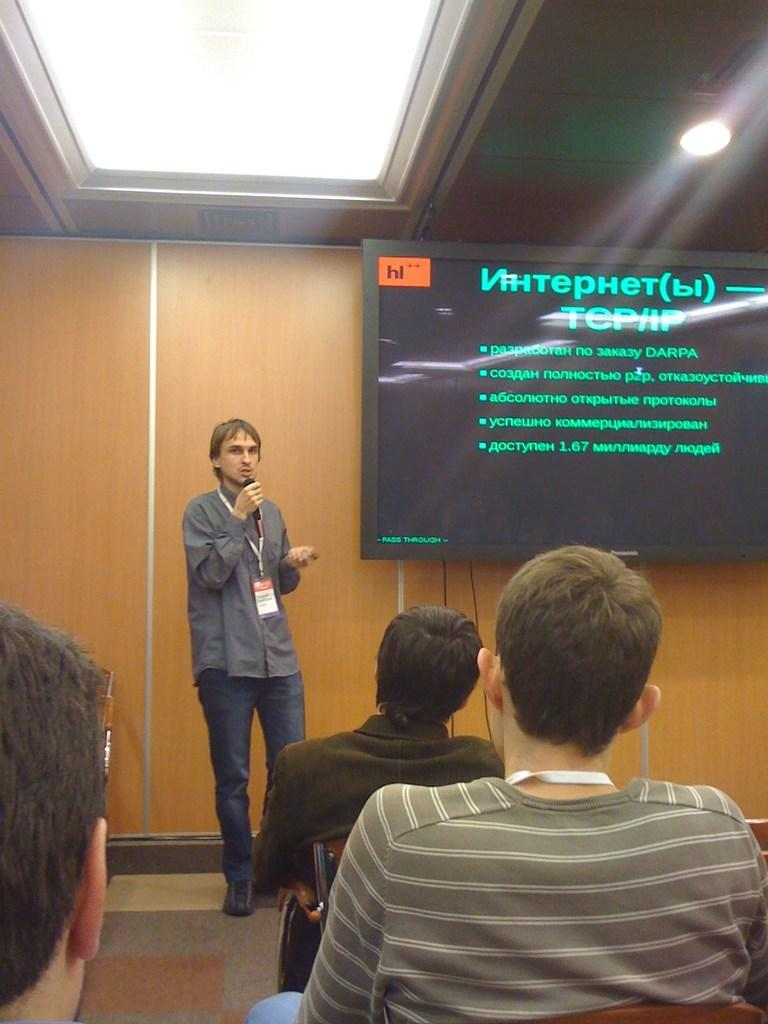What is on the wall in the image? There is a screen on the wall in the image. What type of lighting is present in the image? A light is attached to the ceiling in the image. Who is in the image? A man is standing in the image. What is the man wearing that identifies him? The man is wearing an ID card. What is the man holding in the image? The man is holding a microphone near his lips. What are the people in the image doing? The people are sitting on chairs in the image. What type of pen is the man using to write on the crib in the image? There is no pen or crib present in the image. What color is the dress the man is wearing in the image? The man is not wearing a dress in the image; he is wearing an ID card. 